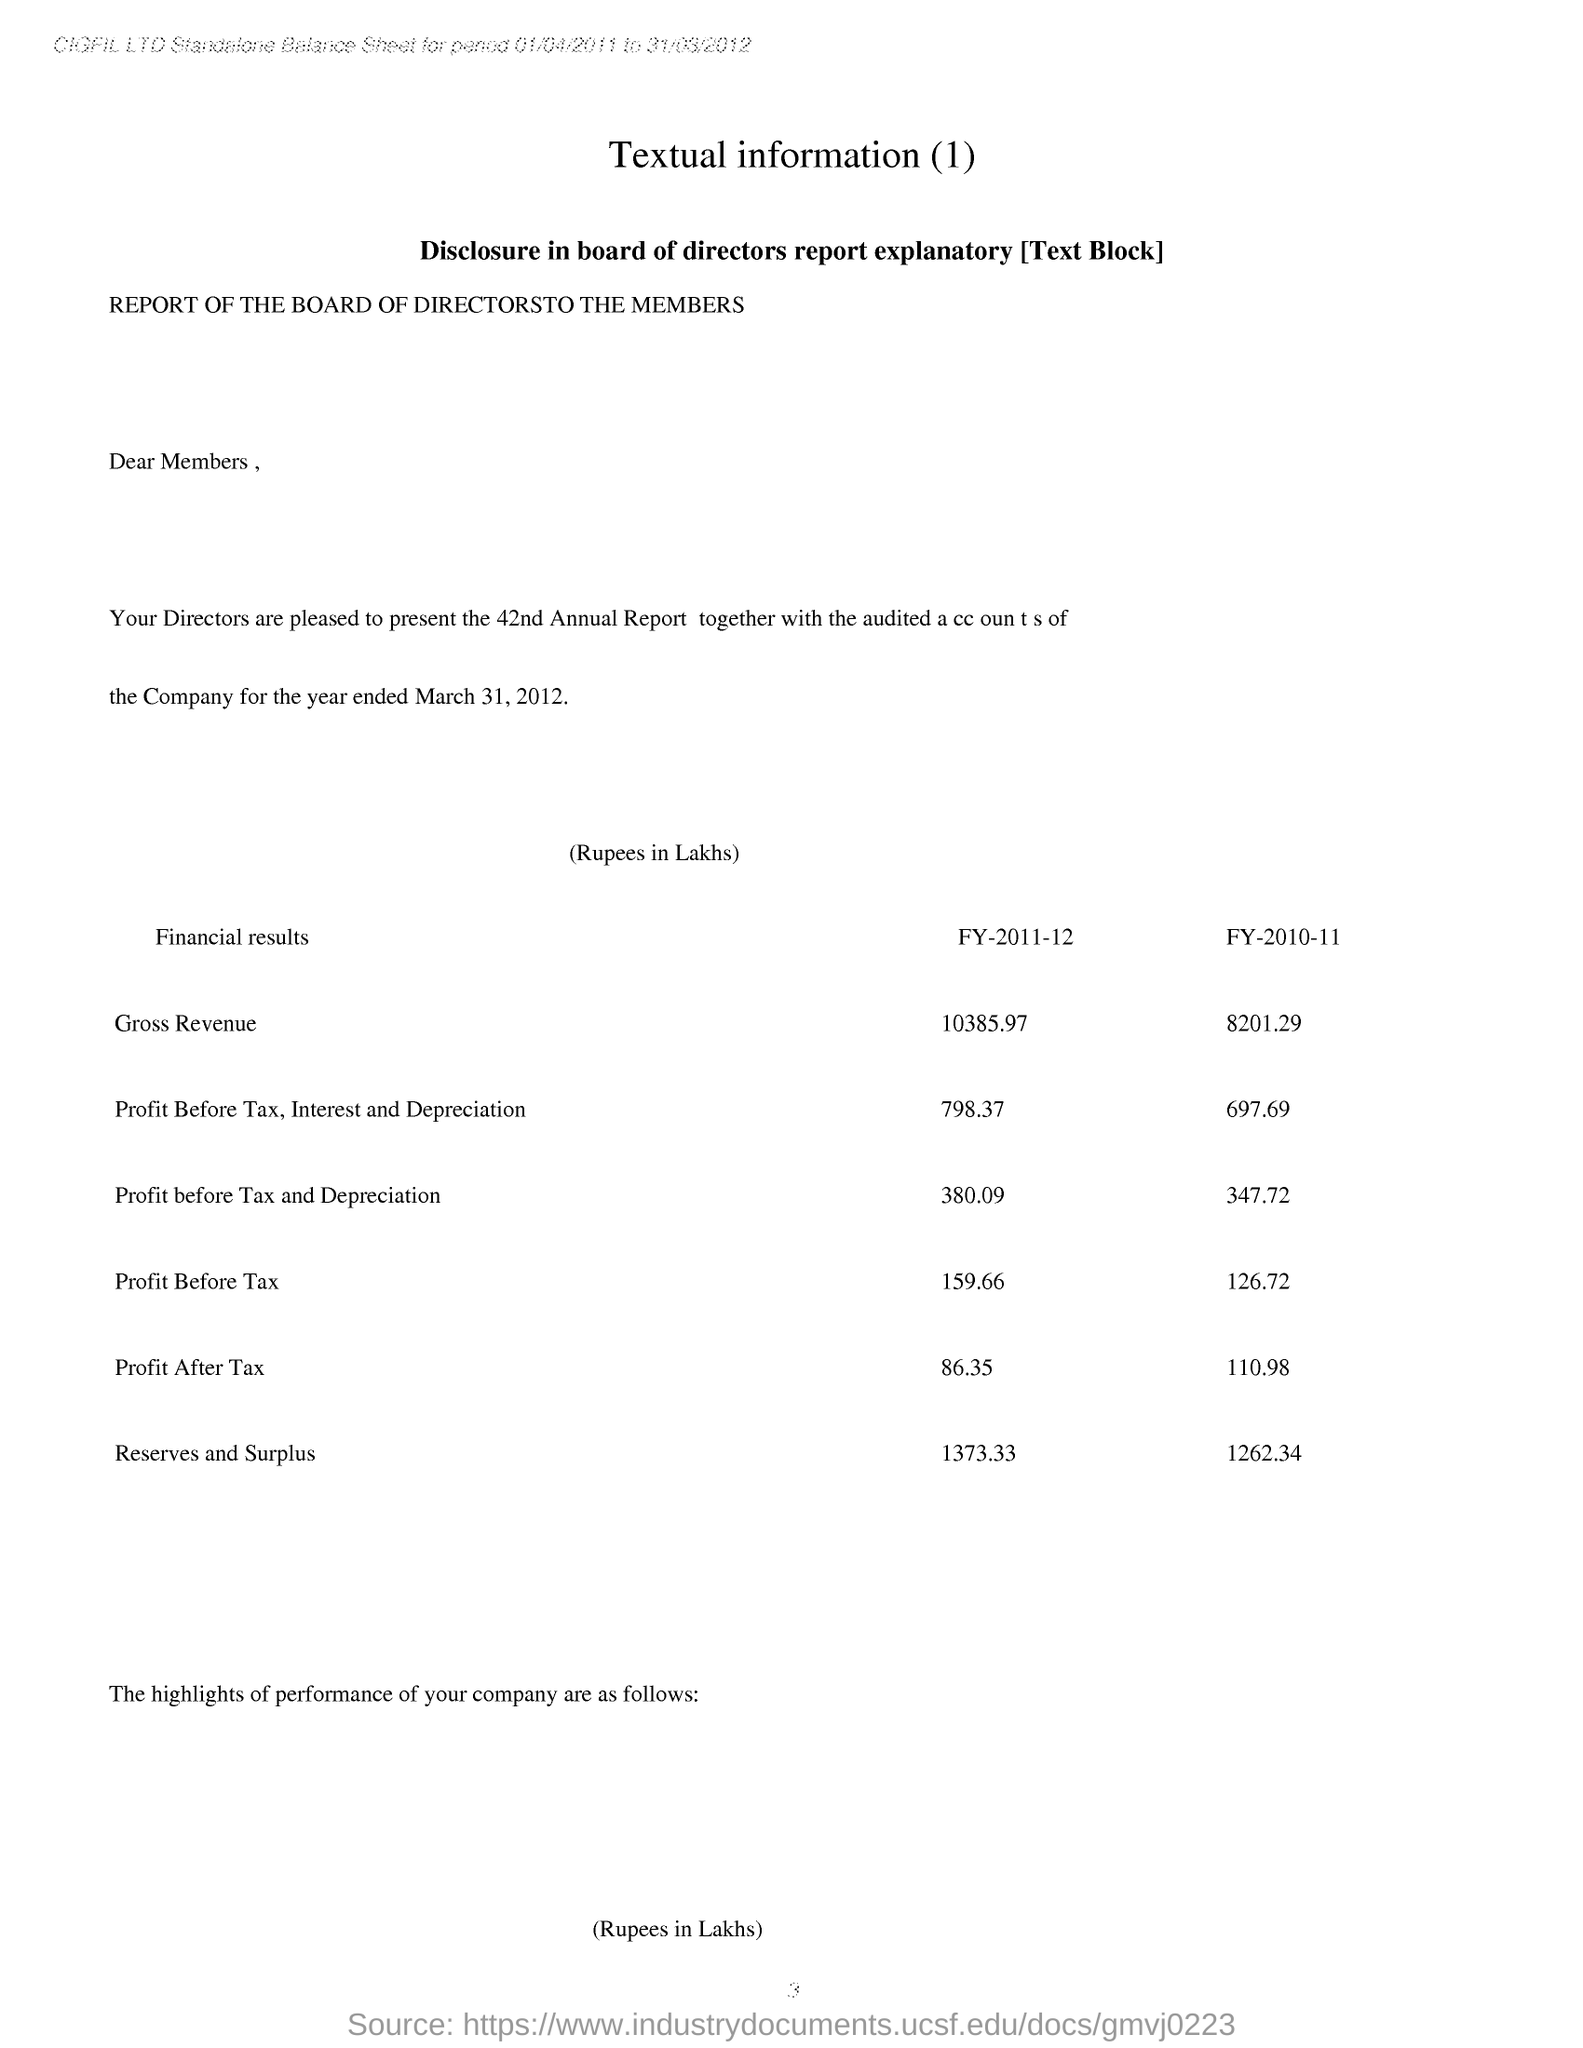Point out several critical features in this image. The profit after tax of the company for the financial year 2011-2012 was 86.35. The Profit Before Tax of the company for the financial year 2011-2012 was 159.66. This page contains a heading that is the heading of this page. 